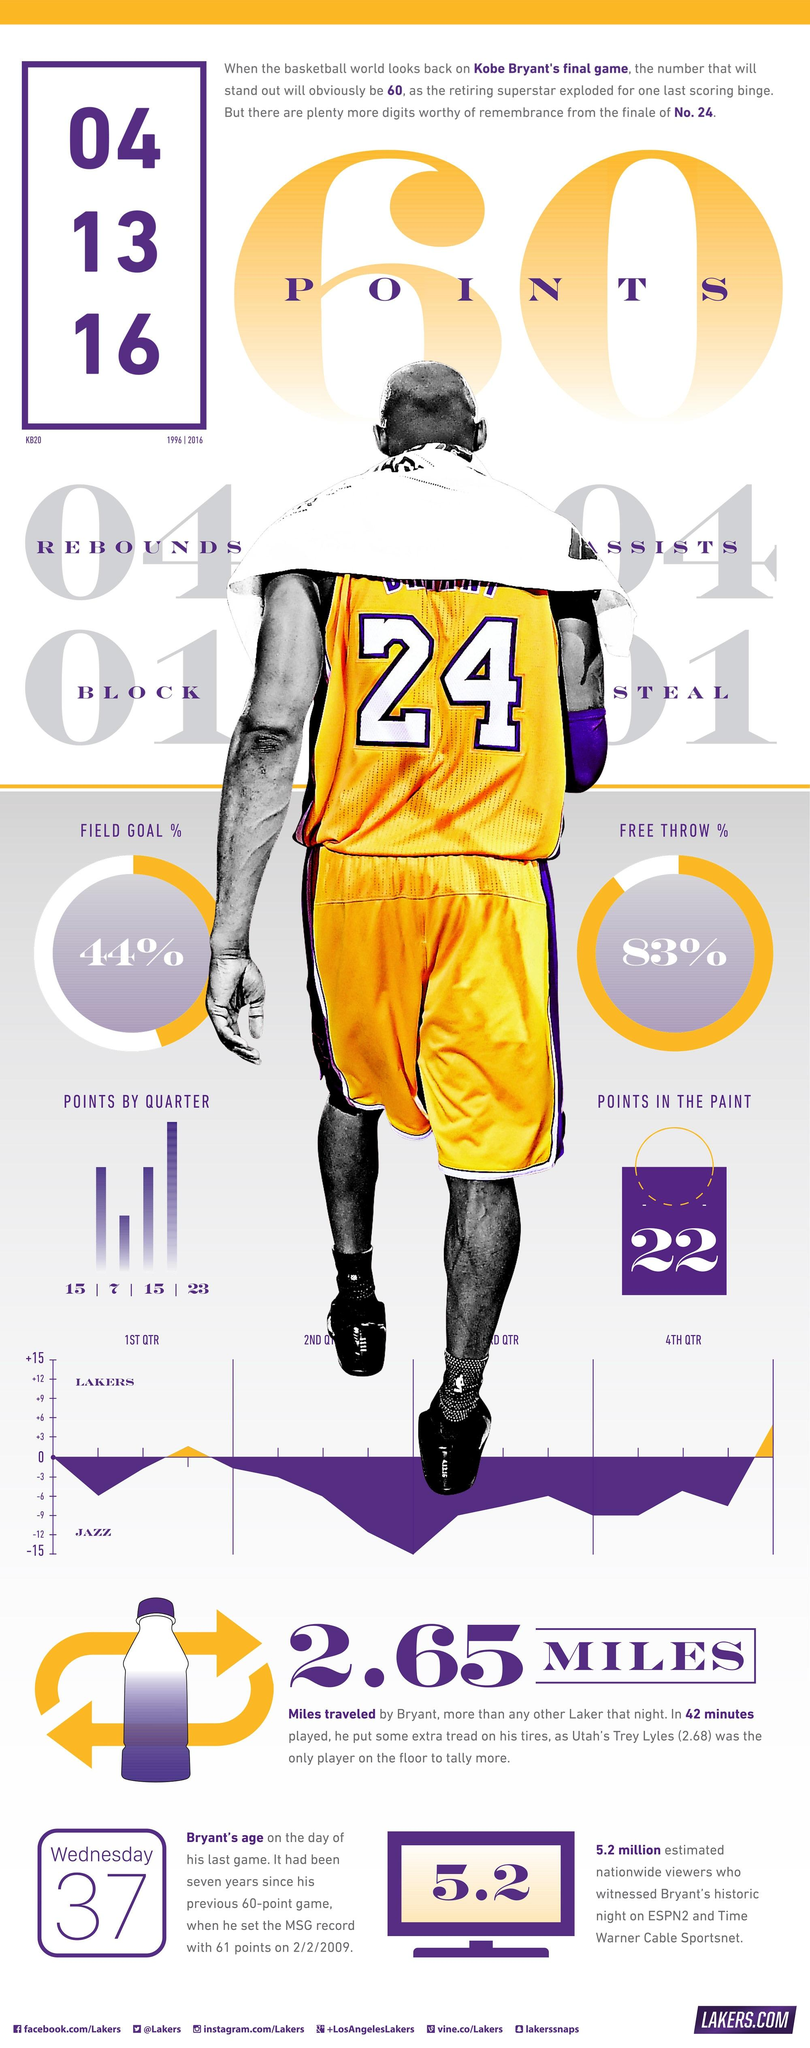Draw attention to some important aspects in this diagram. Kobe Bryant plays for the LA Lakers basketball team. In his final game, Kobe Bryant scored an impressive 22 points in the paint. In Kobe Bryant's final game, he scored 23 points during the fourth quarter. Kobe Bryant was 37 years old when he played his last game. Kobe Bryant's jersey number is 24, 